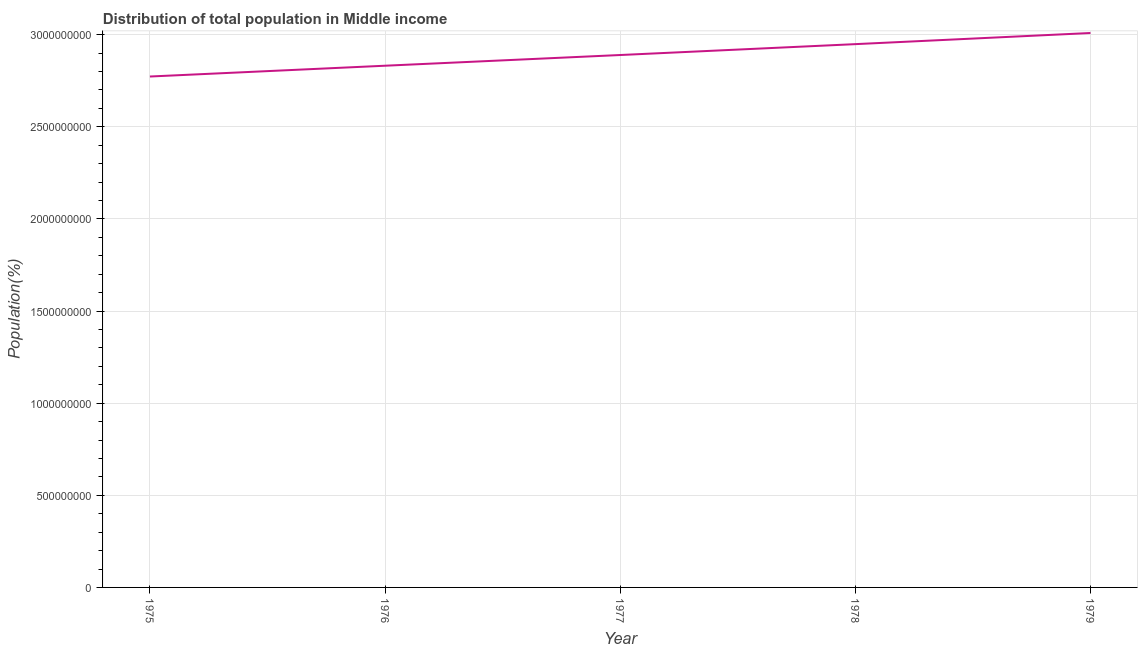What is the population in 1976?
Keep it short and to the point. 2.83e+09. Across all years, what is the maximum population?
Your answer should be compact. 3.01e+09. Across all years, what is the minimum population?
Your answer should be compact. 2.77e+09. In which year was the population maximum?
Give a very brief answer. 1979. In which year was the population minimum?
Make the answer very short. 1975. What is the sum of the population?
Your answer should be very brief. 1.45e+1. What is the difference between the population in 1976 and 1978?
Offer a terse response. -1.17e+08. What is the average population per year?
Make the answer very short. 2.89e+09. What is the median population?
Make the answer very short. 2.89e+09. In how many years, is the population greater than 2700000000 %?
Ensure brevity in your answer.  5. Do a majority of the years between 1975 and 1977 (inclusive) have population greater than 2900000000 %?
Make the answer very short. No. What is the ratio of the population in 1976 to that in 1977?
Make the answer very short. 0.98. What is the difference between the highest and the second highest population?
Your answer should be compact. 6.04e+07. Is the sum of the population in 1975 and 1978 greater than the maximum population across all years?
Offer a very short reply. Yes. What is the difference between the highest and the lowest population?
Provide a succinct answer. 2.36e+08. In how many years, is the population greater than the average population taken over all years?
Offer a terse response. 2. How many years are there in the graph?
Your answer should be compact. 5. Does the graph contain any zero values?
Make the answer very short. No. Does the graph contain grids?
Ensure brevity in your answer.  Yes. What is the title of the graph?
Your answer should be compact. Distribution of total population in Middle income . What is the label or title of the Y-axis?
Keep it short and to the point. Population(%). What is the Population(%) in 1975?
Give a very brief answer. 2.77e+09. What is the Population(%) in 1976?
Provide a succinct answer. 2.83e+09. What is the Population(%) in 1977?
Give a very brief answer. 2.89e+09. What is the Population(%) of 1978?
Provide a short and direct response. 2.95e+09. What is the Population(%) in 1979?
Your response must be concise. 3.01e+09. What is the difference between the Population(%) in 1975 and 1976?
Give a very brief answer. -5.86e+07. What is the difference between the Population(%) in 1975 and 1977?
Keep it short and to the point. -1.17e+08. What is the difference between the Population(%) in 1975 and 1978?
Your response must be concise. -1.76e+08. What is the difference between the Population(%) in 1975 and 1979?
Provide a short and direct response. -2.36e+08. What is the difference between the Population(%) in 1976 and 1977?
Provide a short and direct response. -5.81e+07. What is the difference between the Population(%) in 1976 and 1978?
Make the answer very short. -1.17e+08. What is the difference between the Population(%) in 1976 and 1979?
Ensure brevity in your answer.  -1.78e+08. What is the difference between the Population(%) in 1977 and 1978?
Give a very brief answer. -5.91e+07. What is the difference between the Population(%) in 1977 and 1979?
Make the answer very short. -1.20e+08. What is the difference between the Population(%) in 1978 and 1979?
Your answer should be compact. -6.04e+07. What is the ratio of the Population(%) in 1975 to that in 1976?
Offer a terse response. 0.98. What is the ratio of the Population(%) in 1975 to that in 1978?
Offer a very short reply. 0.94. What is the ratio of the Population(%) in 1975 to that in 1979?
Offer a very short reply. 0.92. What is the ratio of the Population(%) in 1976 to that in 1978?
Give a very brief answer. 0.96. What is the ratio of the Population(%) in 1976 to that in 1979?
Your answer should be compact. 0.94. 